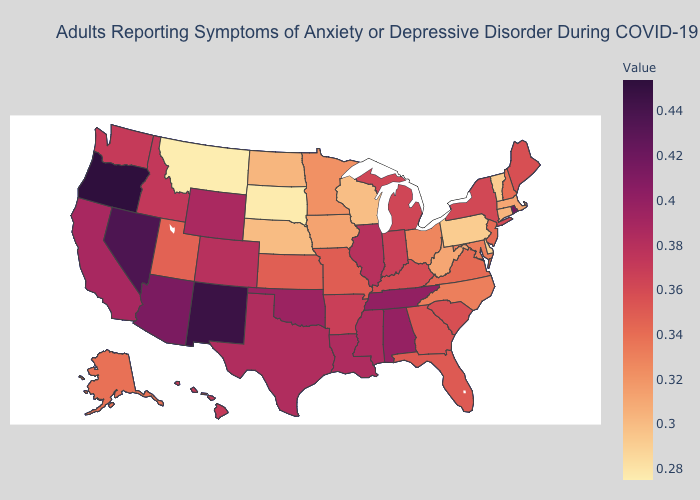Among the states that border Missouri , which have the lowest value?
Quick response, please. Nebraska. Which states have the highest value in the USA?
Quick response, please. Oregon. Among the states that border Texas , does Oklahoma have the highest value?
Be succinct. No. Which states have the lowest value in the South?
Give a very brief answer. Delaware. Which states hav the highest value in the Northeast?
Be succinct. Rhode Island. Does Nebraska have a lower value than Montana?
Answer briefly. No. 